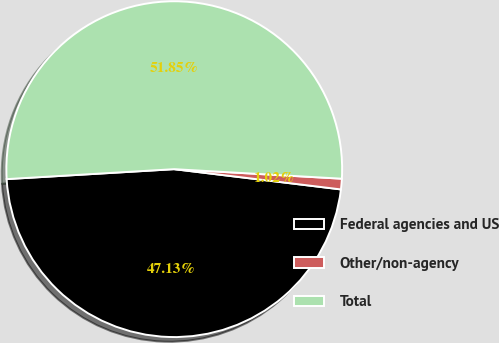Convert chart to OTSL. <chart><loc_0><loc_0><loc_500><loc_500><pie_chart><fcel>Federal agencies and US<fcel>Other/non-agency<fcel>Total<nl><fcel>47.13%<fcel>1.02%<fcel>51.85%<nl></chart> 